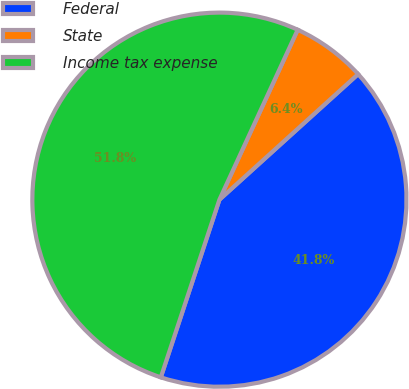Convert chart. <chart><loc_0><loc_0><loc_500><loc_500><pie_chart><fcel>Federal<fcel>State<fcel>Income tax expense<nl><fcel>41.78%<fcel>6.42%<fcel>51.8%<nl></chart> 